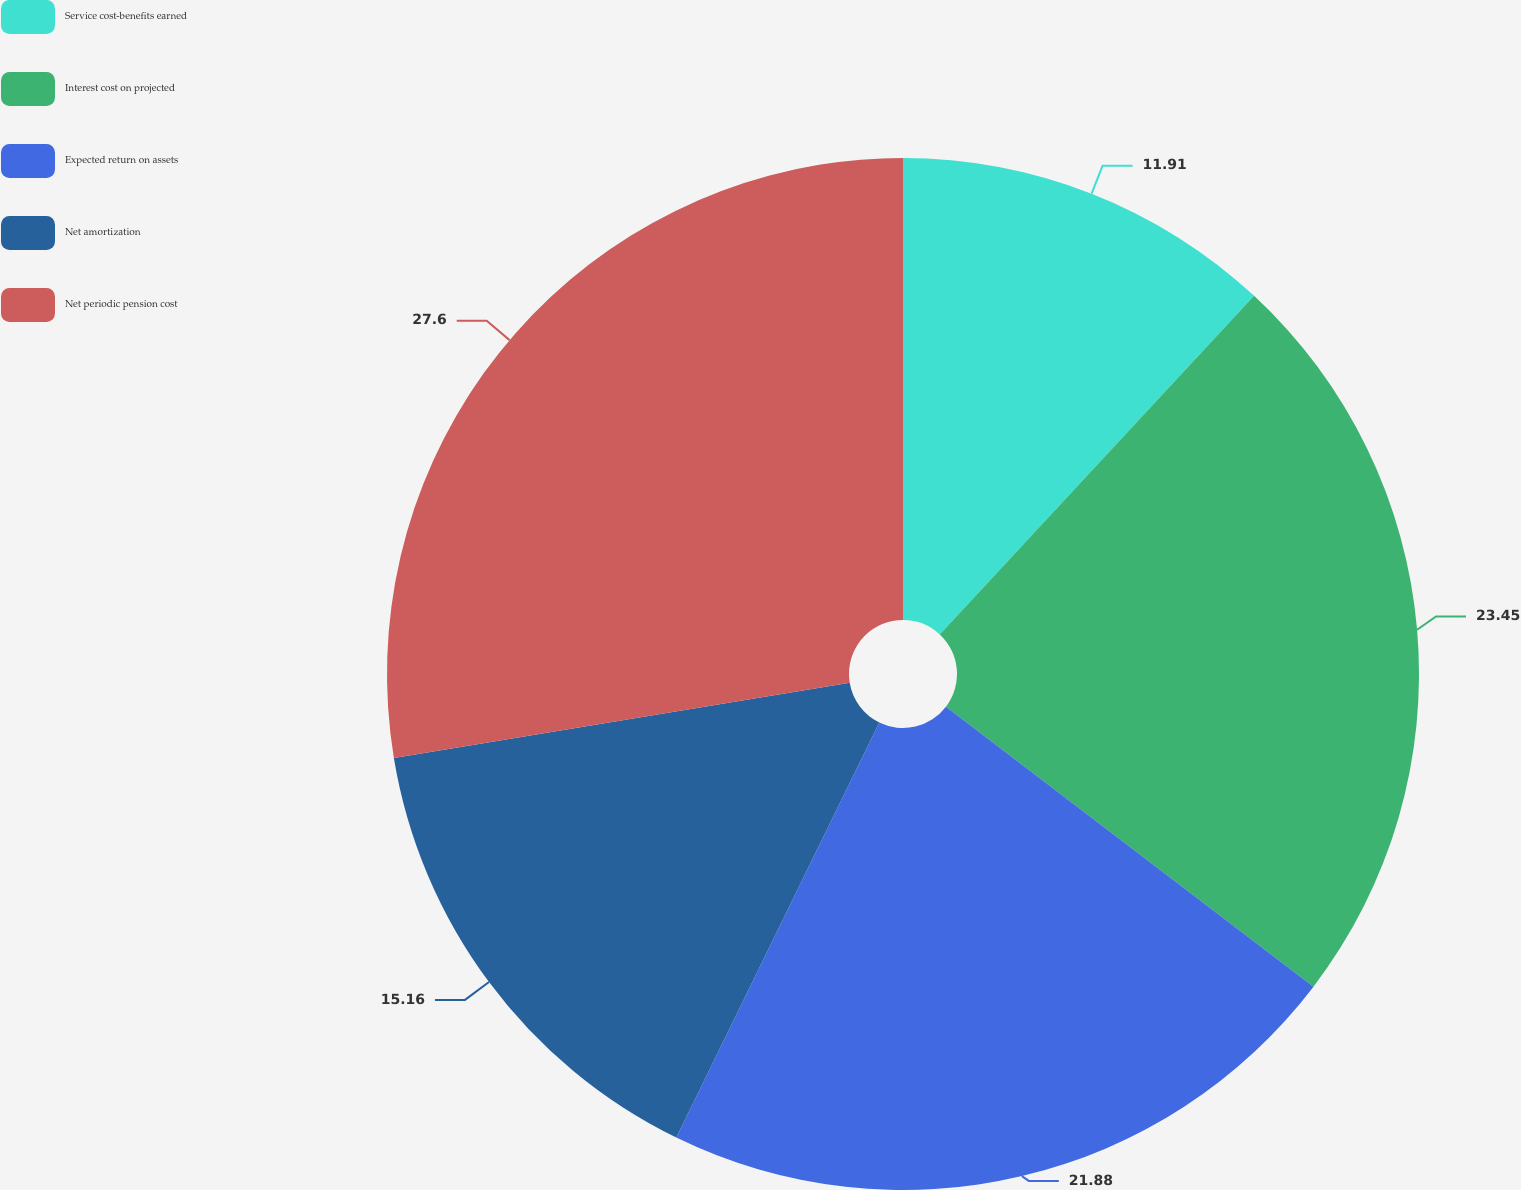<chart> <loc_0><loc_0><loc_500><loc_500><pie_chart><fcel>Service cost-benefits earned<fcel>Interest cost on projected<fcel>Expected return on assets<fcel>Net amortization<fcel>Net periodic pension cost<nl><fcel>11.91%<fcel>23.45%<fcel>21.88%<fcel>15.16%<fcel>27.6%<nl></chart> 